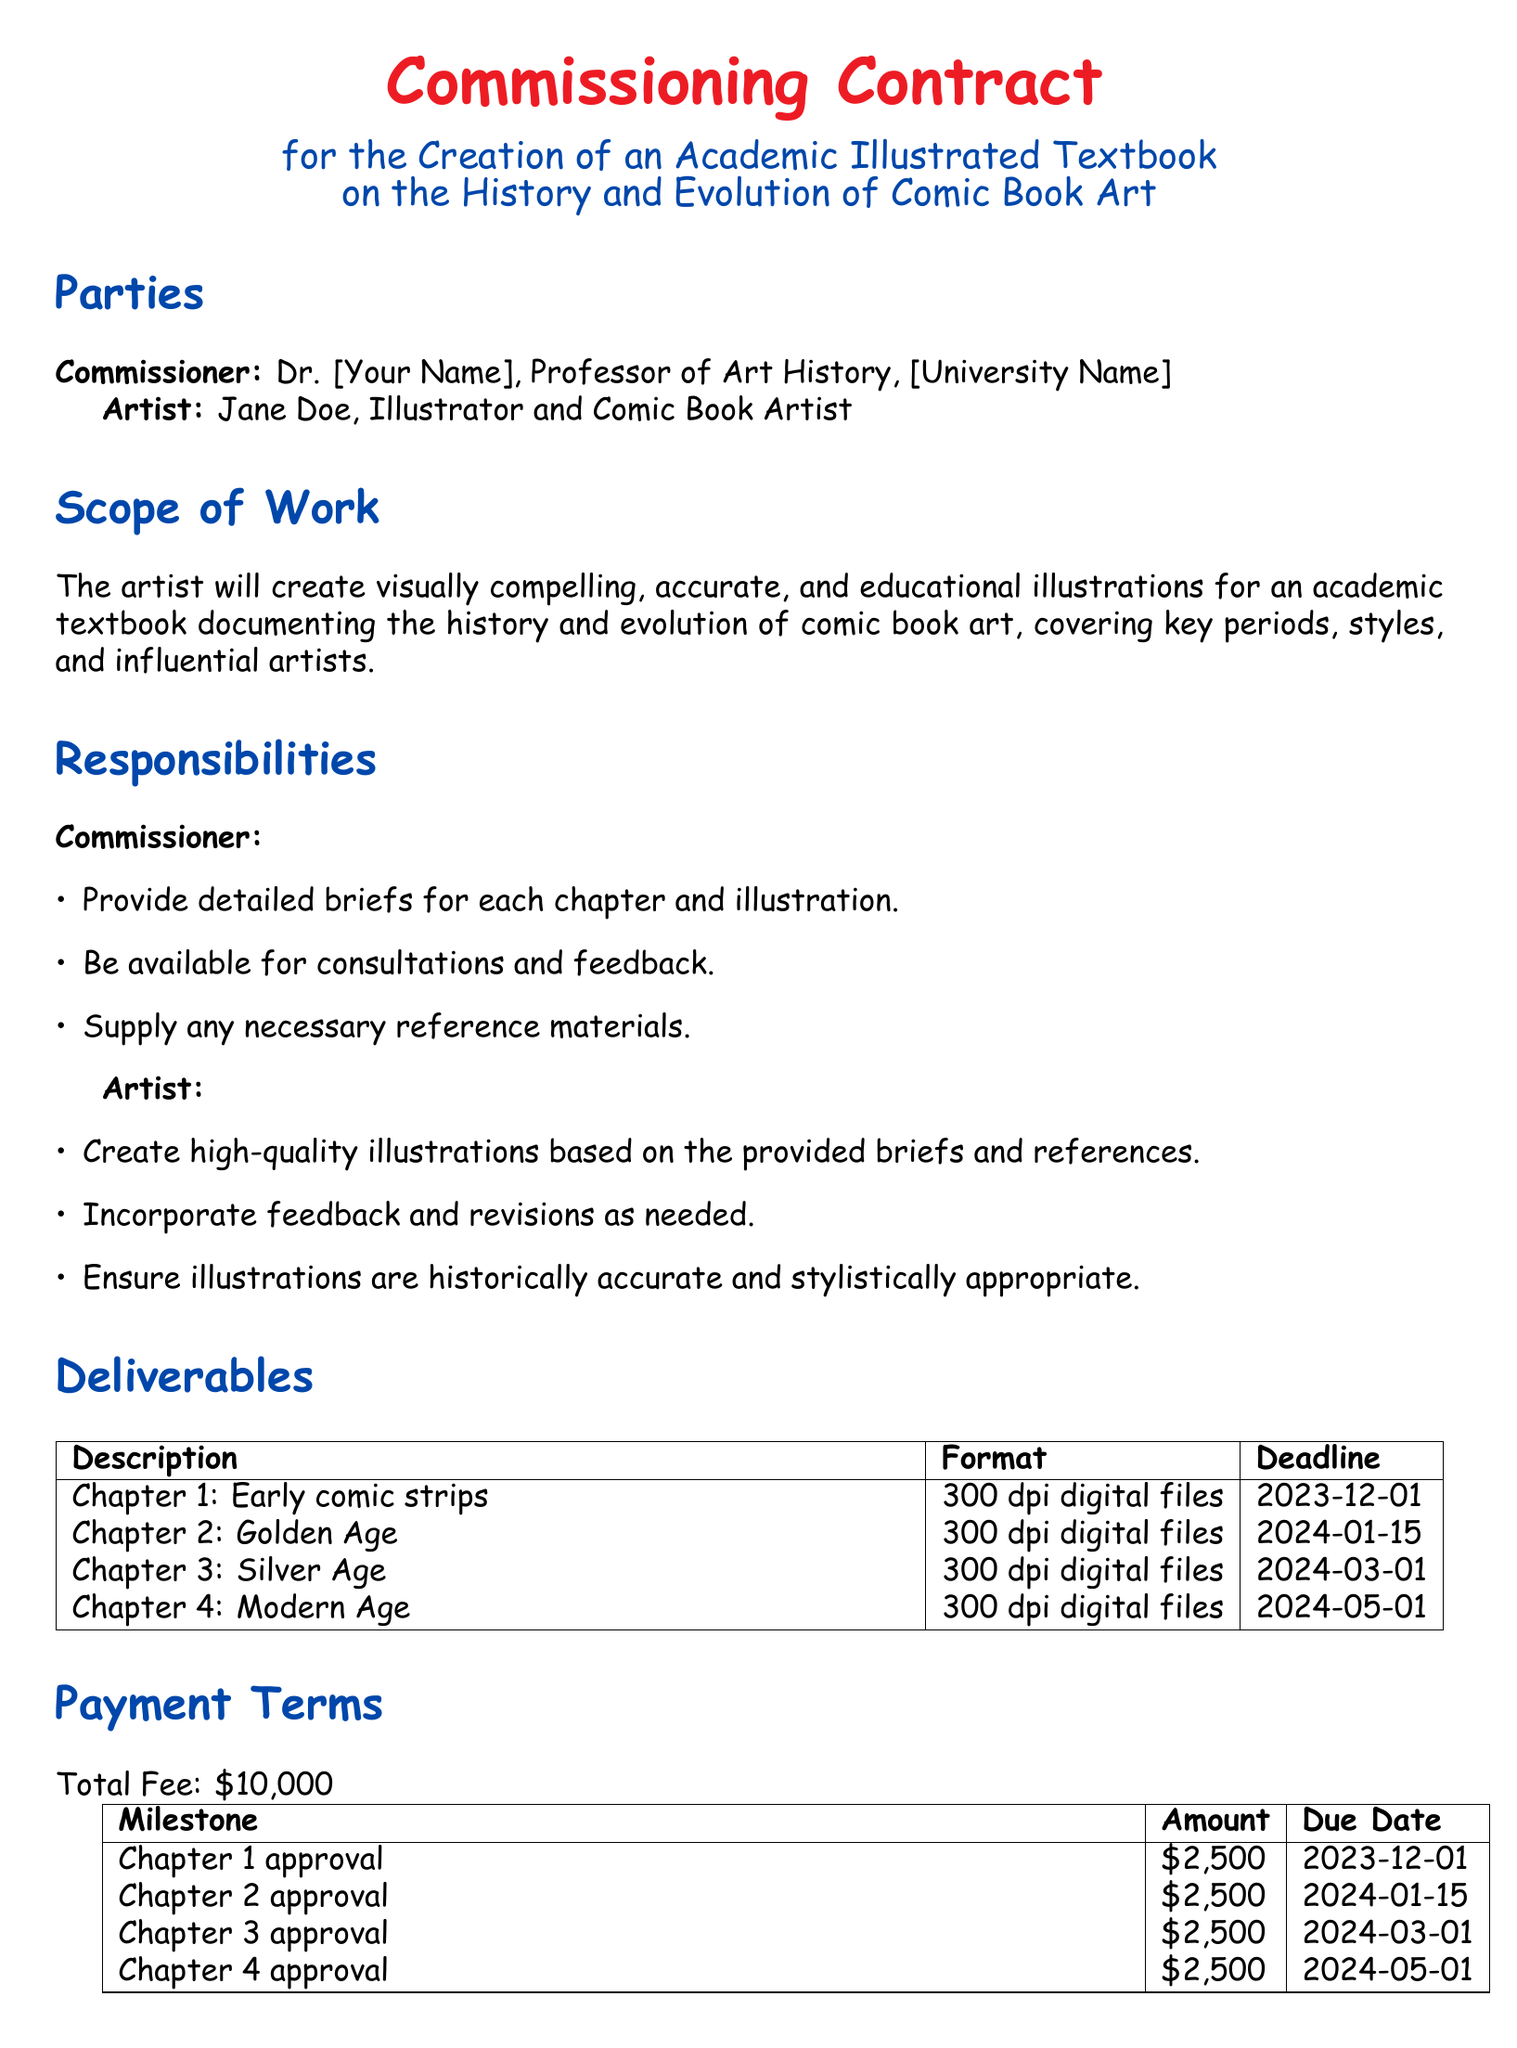What is the total fee for the project? The total fee is stated clearly in the payment terms section of the contract.
Answer: $10,000 What is the deadline for Chapter 2's illustrations? The deadline for Chapter 2 can be found in the deliverables section where all deadlines are listed.
Answer: 2024-01-15 Who is the artist commissioned for this project? The name of the artist is specified in the parties section of the contract.
Answer: Jane Doe How many chapters will be illustrated? The number of chapters is indicated in the deliverables table, showing each chapter laid out.
Answer: 4 What is the payment due date for Chapter 3 approval? The due date for Chapter 3 approval is included in the payments section.
Answer: 2024-03-01 What responsibilities does the artist have according to the contract? The artist's responsibilities are outlined in a dedicated section detailing what is expected from them.
Answer: Create high-quality illustrations What are the artist's payment milestones? The milestones for payments are listed in a table, showing the amount and due dates per chapter.
Answer: Chapter 1 approval, Chapter 2 approval, Chapter 3 approval, Chapter 4 approval What happens if either party wishes to terminate the contract? The termination clause details the procedure and compensation related to contract termination.
Answer: Written notice of 30 days Who is the commissioner of the project? The commissioner is mentioned in the parties section, identifying their role and affiliation.
Answer: Dr. [Your Name] 